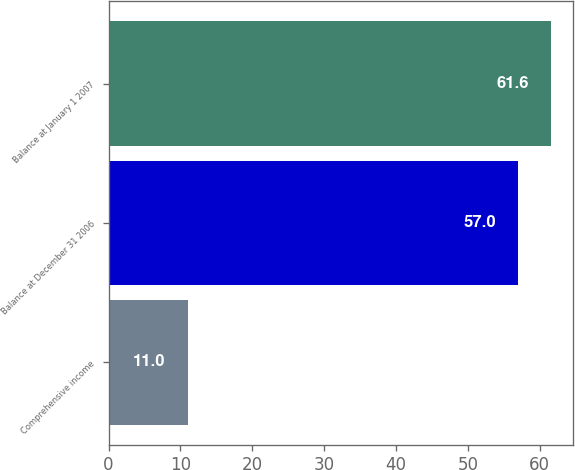Convert chart to OTSL. <chart><loc_0><loc_0><loc_500><loc_500><bar_chart><fcel>Comprehensive income<fcel>Balance at December 31 2006<fcel>Balance at January 1 2007<nl><fcel>11<fcel>57<fcel>61.6<nl></chart> 